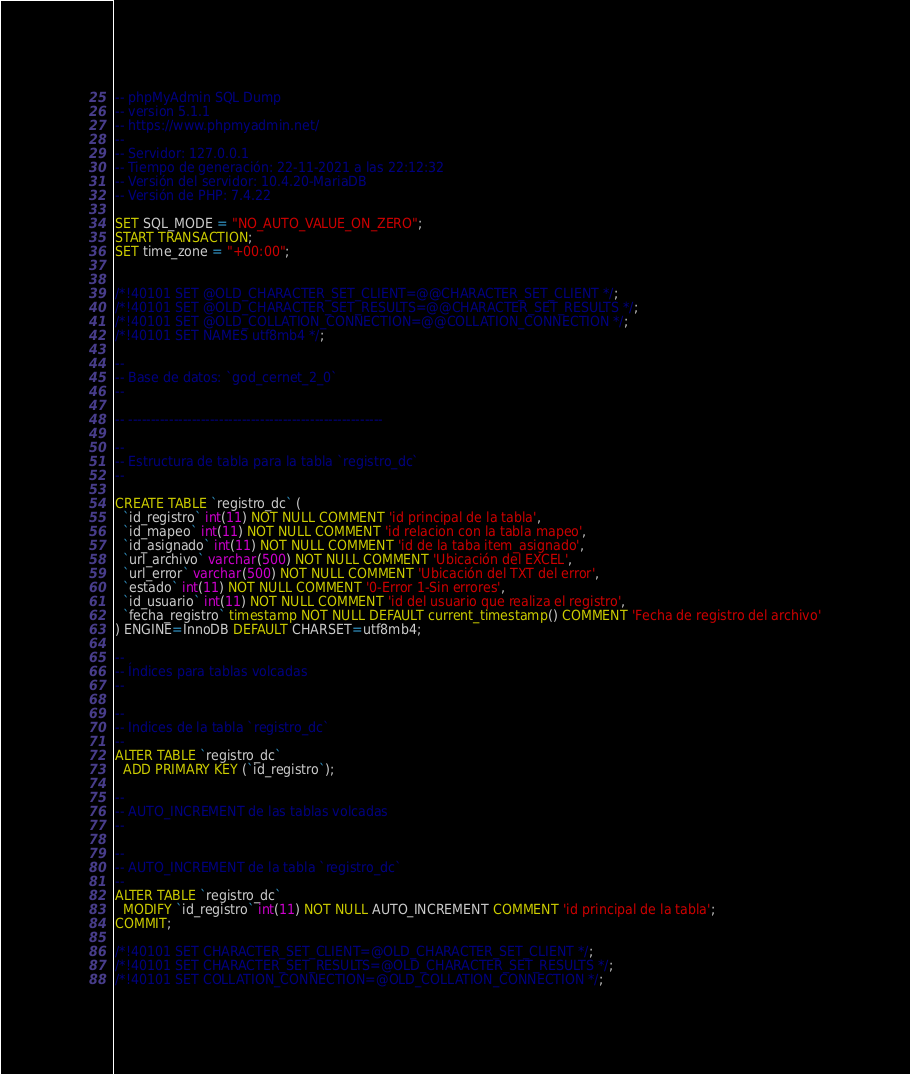<code> <loc_0><loc_0><loc_500><loc_500><_SQL_>-- phpMyAdmin SQL Dump
-- version 5.1.1
-- https://www.phpmyadmin.net/
--
-- Servidor: 127.0.0.1
-- Tiempo de generación: 22-11-2021 a las 22:12:32
-- Versión del servidor: 10.4.20-MariaDB
-- Versión de PHP: 7.4.22

SET SQL_MODE = "NO_AUTO_VALUE_ON_ZERO";
START TRANSACTION;
SET time_zone = "+00:00";


/*!40101 SET @OLD_CHARACTER_SET_CLIENT=@@CHARACTER_SET_CLIENT */;
/*!40101 SET @OLD_CHARACTER_SET_RESULTS=@@CHARACTER_SET_RESULTS */;
/*!40101 SET @OLD_COLLATION_CONNECTION=@@COLLATION_CONNECTION */;
/*!40101 SET NAMES utf8mb4 */;

--
-- Base de datos: `god_cernet_2_0`
--

-- --------------------------------------------------------

--
-- Estructura de tabla para la tabla `registro_dc`
--

CREATE TABLE `registro_dc` (
  `id_registro` int(11) NOT NULL COMMENT 'id principal de la tabla',
  `id_mapeo` int(11) NOT NULL COMMENT 'id relacion con la tabla mapeo',
  `id_asignado` int(11) NOT NULL COMMENT 'id de la taba item_asignado',
  `url_archivo` varchar(500) NOT NULL COMMENT 'Ubicación del EXCEL',
  `url_error` varchar(500) NOT NULL COMMENT 'Ubicación del TXT del error',
  `estado` int(11) NOT NULL COMMENT '0-Error 1-Sin errores',
  `id_usuario` int(11) NOT NULL COMMENT 'id del usuario que realiza el registro',
  `fecha_registro` timestamp NOT NULL DEFAULT current_timestamp() COMMENT 'Fecha de registro del archivo'
) ENGINE=InnoDB DEFAULT CHARSET=utf8mb4;

--
-- Índices para tablas volcadas
--

--
-- Indices de la tabla `registro_dc`
--
ALTER TABLE `registro_dc`
  ADD PRIMARY KEY (`id_registro`);

--
-- AUTO_INCREMENT de las tablas volcadas
--

--
-- AUTO_INCREMENT de la tabla `registro_dc`
--
ALTER TABLE `registro_dc`
  MODIFY `id_registro` int(11) NOT NULL AUTO_INCREMENT COMMENT 'id principal de la tabla';
COMMIT;

/*!40101 SET CHARACTER_SET_CLIENT=@OLD_CHARACTER_SET_CLIENT */;
/*!40101 SET CHARACTER_SET_RESULTS=@OLD_CHARACTER_SET_RESULTS */;
/*!40101 SET COLLATION_CONNECTION=@OLD_COLLATION_CONNECTION */;
</code> 